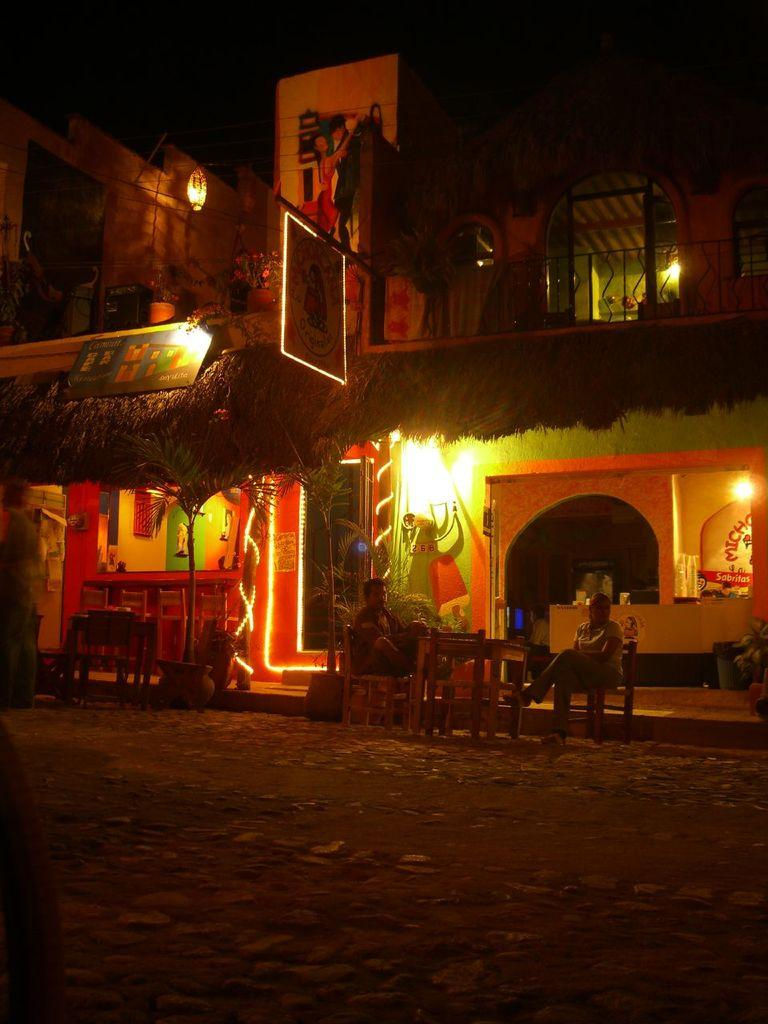What type of structure is present in the image? There is a house in the image. What feature of the house is mentioned in the facts? The house has lighting. What furniture is visible in the image? There are chairs and a table in the image. What are the persons in the image doing? There are persons sitting on the chairs. Can you hear a whistle in the image? There is no mention of a whistle in the image, so it cannot be heard. Is there a sister sitting on one of the chairs? There is no mention of a sister or any specific person sitting on the chairs, only that there are persons sitting on the chairs. 